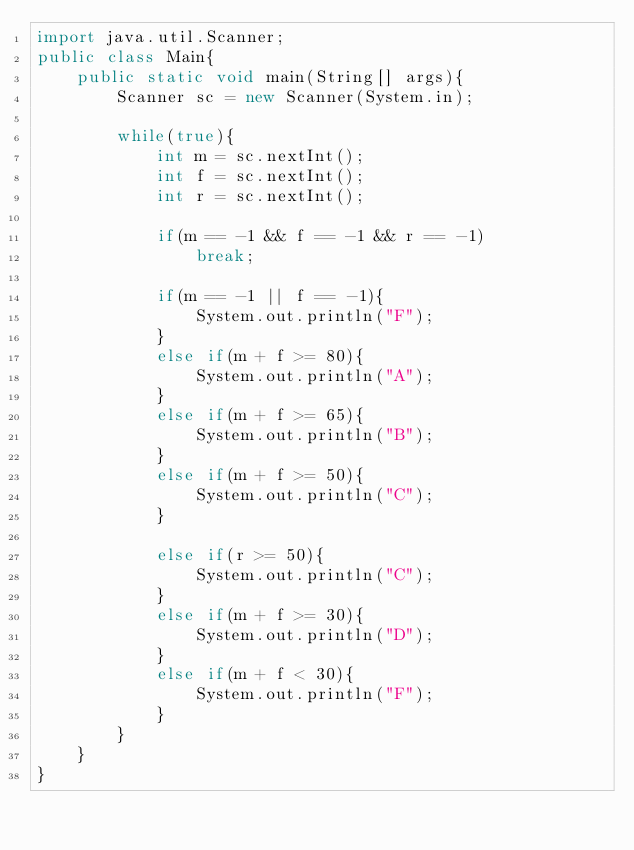Convert code to text. <code><loc_0><loc_0><loc_500><loc_500><_Java_>import java.util.Scanner;
public class Main{
    public static void main(String[] args){
        Scanner sc = new Scanner(System.in);
        
        while(true){
            int m = sc.nextInt();
            int f = sc.nextInt();
            int r = sc.nextInt();
            
            if(m == -1 && f == -1 && r == -1)
                break;
            
            if(m == -1 || f == -1){
                System.out.println("F");
            }
            else if(m + f >= 80){
                System.out.println("A");
            }
            else if(m + f >= 65){
                System.out.println("B");
            }
            else if(m + f >= 50){
                System.out.println("C");
            }
            
            else if(r >= 50){
                System.out.println("C");
            }
            else if(m + f >= 30){
                System.out.println("D");
            }
            else if(m + f < 30){
                System.out.println("F");
            }   
        }
    }
}

</code> 